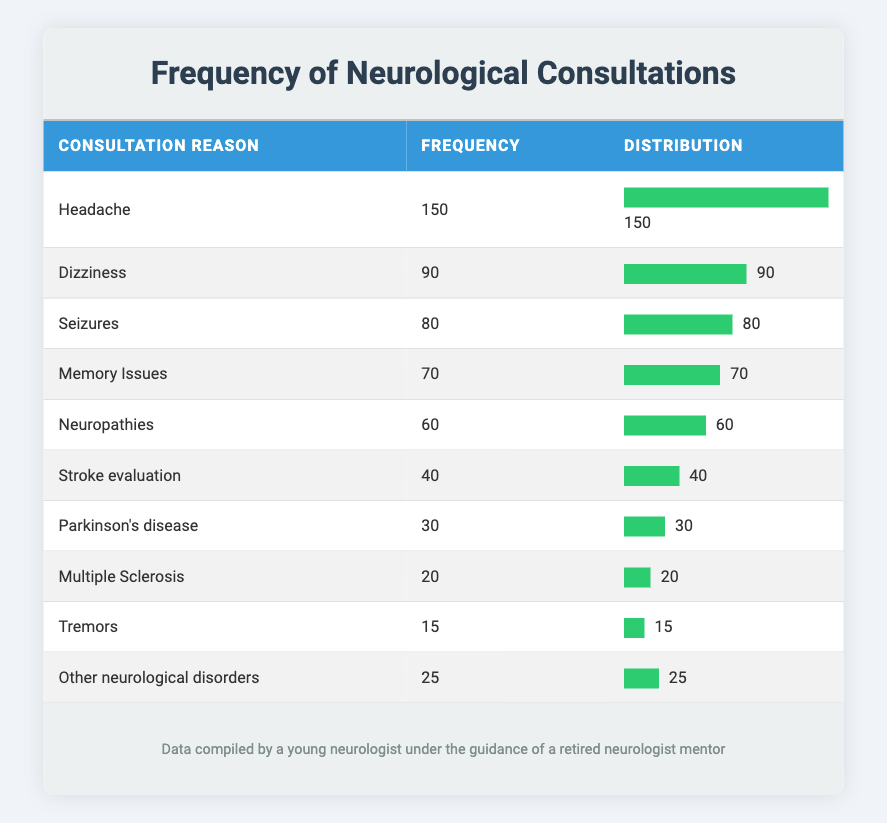What is the reason for the highest frequency of consultations? The highest frequency of consultations is for "Headache," which has a frequency of 150. This can be identified easily by scanning the frequency column for the maximum value.
Answer: Headache How many consultations were requested for "Dizziness"? The frequency for "Dizziness" is 90, which is directly available in the table.
Answer: 90 What is the total frequency of consultations for "Memory Issues" and "Neuropathies"? First, locate the frequencies for each: "Memory Issues" has a frequency of 70 and "Neuropathies" has a frequency of 60. Adding these frequencies gives: 70 + 60 = 130.
Answer: 130 Is the frequency of "Multiple Sclerosis" higher than that of "Parkinson's disease"? "Multiple Sclerosis" has a frequency of 20 and "Parkinson's disease" has a frequency of 30. Since 20 is less than 30, the statement is false.
Answer: No What percentage of the total consultations does "Seizures" represent? To find the percentage, first calculate the total frequency of all consultations: 150 + 90 + 80 + 70 + 60 + 40 + 30 + 20 + 15 + 25 = 570. Then, divide the frequency of "Seizures", which is 80, by the total (80/570) and multiply by 100 to get the percentage: (80 / 570) * 100 ≈ 14.04%.
Answer: Approximately 14.04% What is the average frequency of consultations for all disorders listed? To find the average frequency, sum all the frequencies: 150 + 90 + 80 + 70 + 60 + 40 + 30 + 20 + 15 + 25 = 570. Since there are 10 different reasons for consultations, divide the total by 10: 570 / 10 = 57.
Answer: 57 Which consultation category has the least frequency? Scanning the frequency column, "Multiple Sclerosis" has the lowest frequency of 20 among the consultation reasons.
Answer: Multiple Sclerosis What is the difference in frequency between "Stroke evaluation" and "Other neurological disorders"? "Stroke evaluation" has a frequency of 40, and "Other neurological disorders" has a frequency of 25. Subtracting the latter from the former gives: 40 - 25 = 15.
Answer: 15 